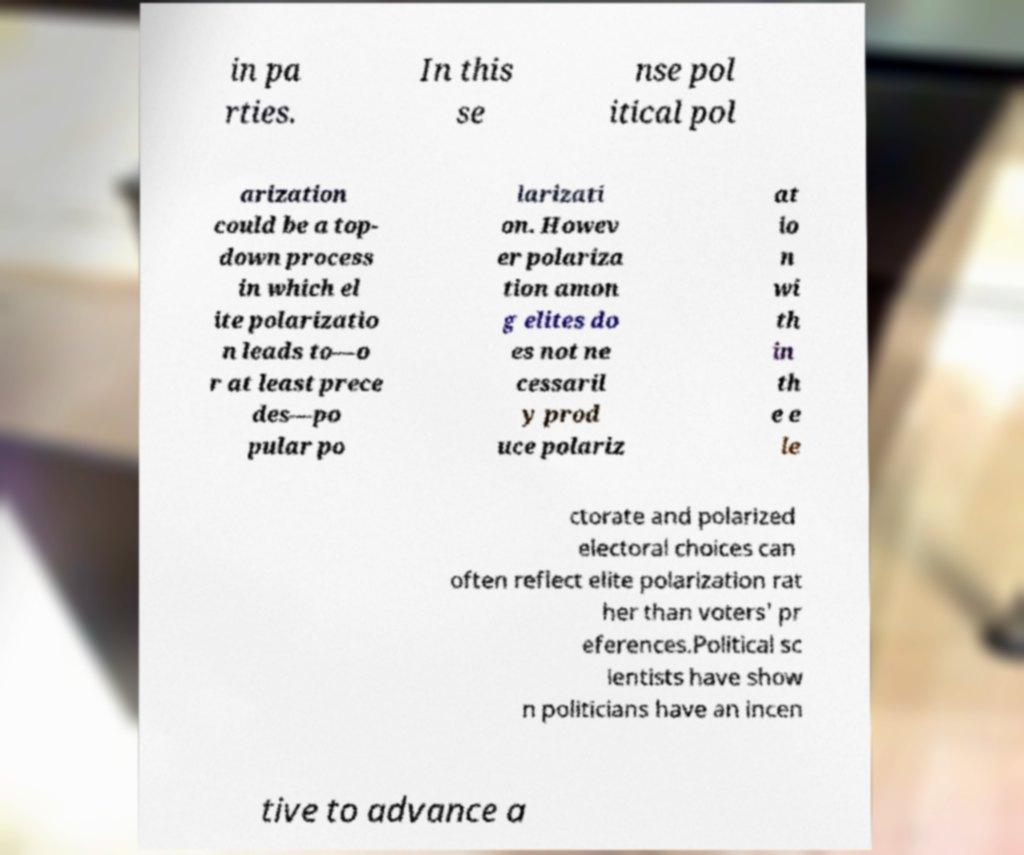Could you extract and type out the text from this image? in pa rties. In this se nse pol itical pol arization could be a top- down process in which el ite polarizatio n leads to—o r at least prece des—po pular po larizati on. Howev er polariza tion amon g elites do es not ne cessaril y prod uce polariz at io n wi th in th e e le ctorate and polarized electoral choices can often reflect elite polarization rat her than voters' pr eferences.Political sc ientists have show n politicians have an incen tive to advance a 